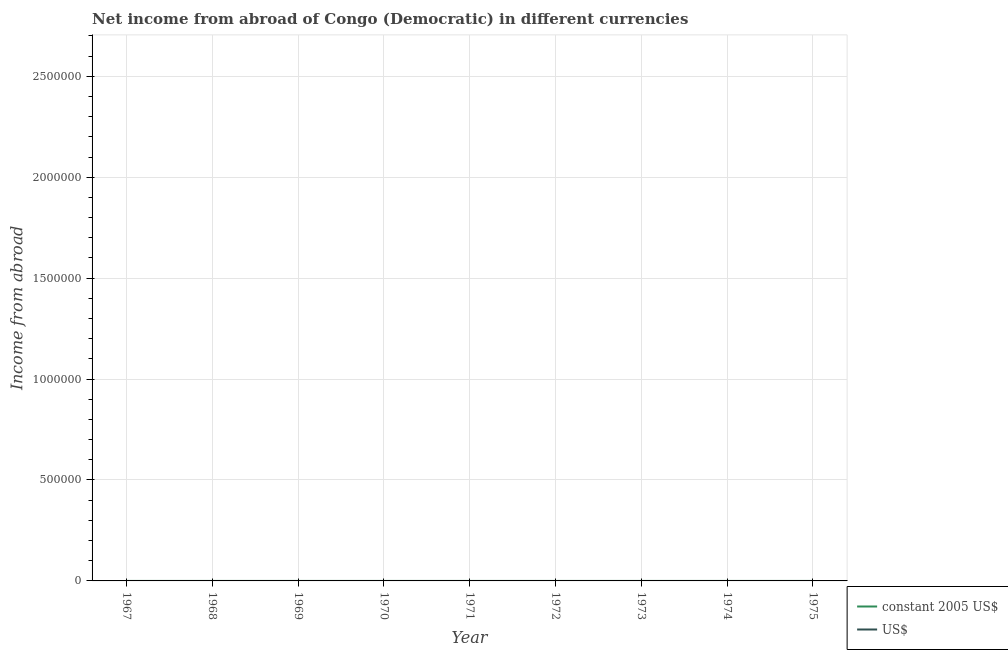How many different coloured lines are there?
Your response must be concise. 0. Does the line corresponding to income from abroad in us$ intersect with the line corresponding to income from abroad in constant 2005 us$?
Provide a succinct answer. No. What is the income from abroad in us$ in 1970?
Provide a succinct answer. 0. Across all years, what is the minimum income from abroad in constant 2005 us$?
Provide a short and direct response. 0. What is the total income from abroad in us$ in the graph?
Provide a succinct answer. 0. What is the difference between the income from abroad in constant 2005 us$ in 1970 and the income from abroad in us$ in 1975?
Give a very brief answer. 0. In how many years, is the income from abroad in constant 2005 us$ greater than the average income from abroad in constant 2005 us$ taken over all years?
Offer a terse response. 0. Does the income from abroad in constant 2005 us$ monotonically increase over the years?
Keep it short and to the point. No. How many lines are there?
Your answer should be compact. 0. Are the values on the major ticks of Y-axis written in scientific E-notation?
Provide a succinct answer. No. Does the graph contain any zero values?
Provide a short and direct response. Yes. What is the title of the graph?
Your answer should be compact. Net income from abroad of Congo (Democratic) in different currencies. What is the label or title of the X-axis?
Ensure brevity in your answer.  Year. What is the label or title of the Y-axis?
Your answer should be compact. Income from abroad. What is the Income from abroad of constant 2005 US$ in 1968?
Offer a terse response. 0. What is the Income from abroad of constant 2005 US$ in 1969?
Keep it short and to the point. 0. What is the Income from abroad in constant 2005 US$ in 1970?
Your answer should be very brief. 0. What is the Income from abroad of US$ in 1971?
Your answer should be compact. 0. What is the Income from abroad in constant 2005 US$ in 1972?
Your response must be concise. 0. What is the Income from abroad of US$ in 1973?
Ensure brevity in your answer.  0. What is the Income from abroad of constant 2005 US$ in 1974?
Make the answer very short. 0. What is the Income from abroad in constant 2005 US$ in 1975?
Keep it short and to the point. 0. What is the total Income from abroad in US$ in the graph?
Provide a short and direct response. 0. What is the average Income from abroad in US$ per year?
Your response must be concise. 0. 